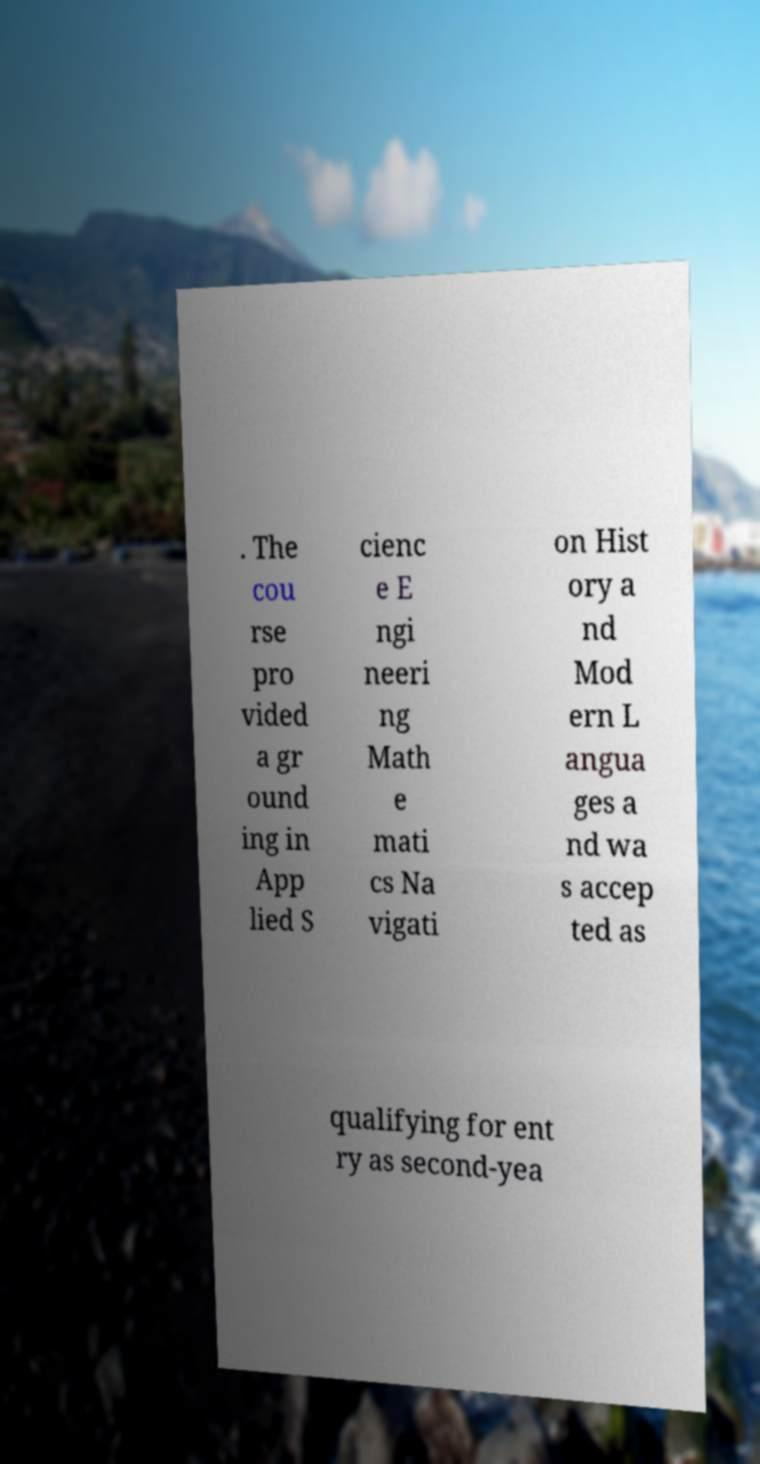Can you read and provide the text displayed in the image?This photo seems to have some interesting text. Can you extract and type it out for me? . The cou rse pro vided a gr ound ing in App lied S cienc e E ngi neeri ng Math e mati cs Na vigati on Hist ory a nd Mod ern L angua ges a nd wa s accep ted as qualifying for ent ry as second-yea 